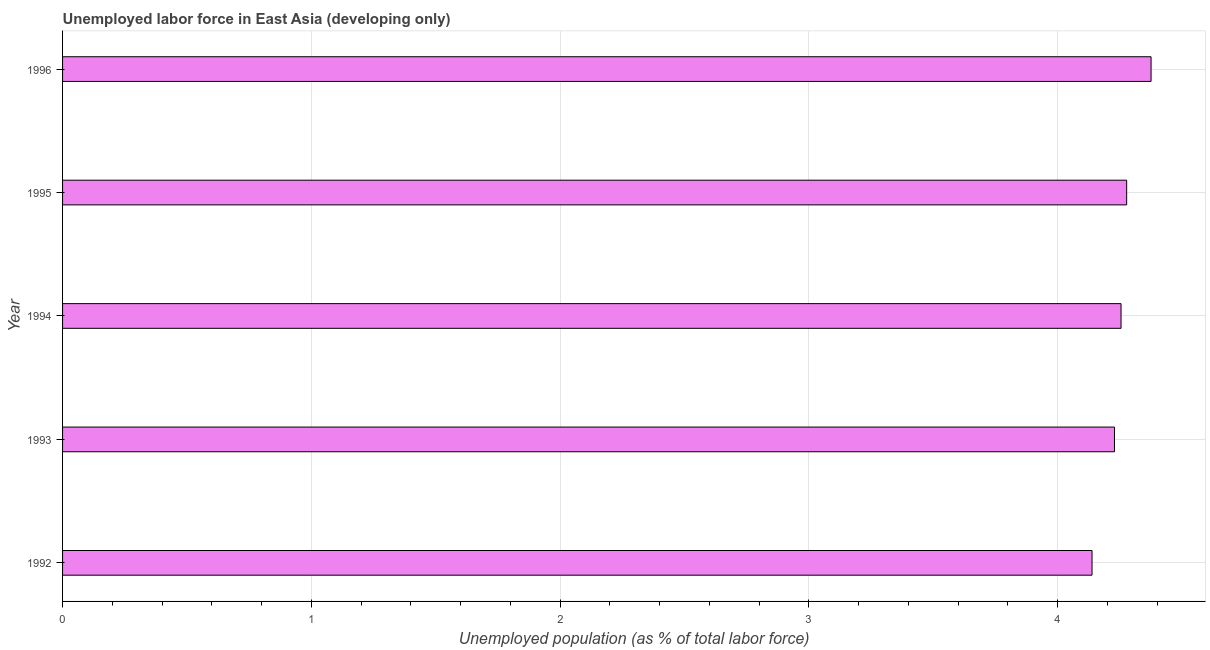Does the graph contain grids?
Make the answer very short. Yes. What is the title of the graph?
Offer a very short reply. Unemployed labor force in East Asia (developing only). What is the label or title of the X-axis?
Provide a short and direct response. Unemployed population (as % of total labor force). What is the label or title of the Y-axis?
Provide a succinct answer. Year. What is the total unemployed population in 1996?
Provide a short and direct response. 4.38. Across all years, what is the maximum total unemployed population?
Make the answer very short. 4.38. Across all years, what is the minimum total unemployed population?
Give a very brief answer. 4.14. In which year was the total unemployed population maximum?
Keep it short and to the point. 1996. What is the sum of the total unemployed population?
Make the answer very short. 21.27. What is the difference between the total unemployed population in 1993 and 1994?
Ensure brevity in your answer.  -0.03. What is the average total unemployed population per year?
Your answer should be very brief. 4.25. What is the median total unemployed population?
Ensure brevity in your answer.  4.25. In how many years, is the total unemployed population greater than 3.8 %?
Your answer should be very brief. 5. Do a majority of the years between 1993 and 1994 (inclusive) have total unemployed population greater than 1.2 %?
Give a very brief answer. Yes. Is the total unemployed population in 1993 less than that in 1995?
Make the answer very short. Yes. What is the difference between the highest and the second highest total unemployed population?
Your answer should be compact. 0.1. What is the difference between the highest and the lowest total unemployed population?
Keep it short and to the point. 0.24. In how many years, is the total unemployed population greater than the average total unemployed population taken over all years?
Your answer should be compact. 2. Are all the bars in the graph horizontal?
Offer a terse response. Yes. What is the difference between two consecutive major ticks on the X-axis?
Ensure brevity in your answer.  1. Are the values on the major ticks of X-axis written in scientific E-notation?
Ensure brevity in your answer.  No. What is the Unemployed population (as % of total labor force) of 1992?
Offer a very short reply. 4.14. What is the Unemployed population (as % of total labor force) of 1993?
Your response must be concise. 4.23. What is the Unemployed population (as % of total labor force) of 1994?
Give a very brief answer. 4.25. What is the Unemployed population (as % of total labor force) in 1995?
Ensure brevity in your answer.  4.28. What is the Unemployed population (as % of total labor force) of 1996?
Your answer should be compact. 4.38. What is the difference between the Unemployed population (as % of total labor force) in 1992 and 1993?
Provide a succinct answer. -0.09. What is the difference between the Unemployed population (as % of total labor force) in 1992 and 1994?
Offer a very short reply. -0.12. What is the difference between the Unemployed population (as % of total labor force) in 1992 and 1995?
Keep it short and to the point. -0.14. What is the difference between the Unemployed population (as % of total labor force) in 1992 and 1996?
Provide a short and direct response. -0.24. What is the difference between the Unemployed population (as % of total labor force) in 1993 and 1994?
Your response must be concise. -0.03. What is the difference between the Unemployed population (as % of total labor force) in 1993 and 1995?
Give a very brief answer. -0.05. What is the difference between the Unemployed population (as % of total labor force) in 1993 and 1996?
Ensure brevity in your answer.  -0.15. What is the difference between the Unemployed population (as % of total labor force) in 1994 and 1995?
Make the answer very short. -0.02. What is the difference between the Unemployed population (as % of total labor force) in 1994 and 1996?
Your answer should be compact. -0.12. What is the difference between the Unemployed population (as % of total labor force) in 1995 and 1996?
Keep it short and to the point. -0.1. What is the ratio of the Unemployed population (as % of total labor force) in 1992 to that in 1993?
Offer a terse response. 0.98. What is the ratio of the Unemployed population (as % of total labor force) in 1992 to that in 1996?
Provide a succinct answer. 0.95. What is the ratio of the Unemployed population (as % of total labor force) in 1993 to that in 1996?
Provide a succinct answer. 0.97. What is the ratio of the Unemployed population (as % of total labor force) in 1994 to that in 1996?
Give a very brief answer. 0.97. What is the ratio of the Unemployed population (as % of total labor force) in 1995 to that in 1996?
Provide a short and direct response. 0.98. 